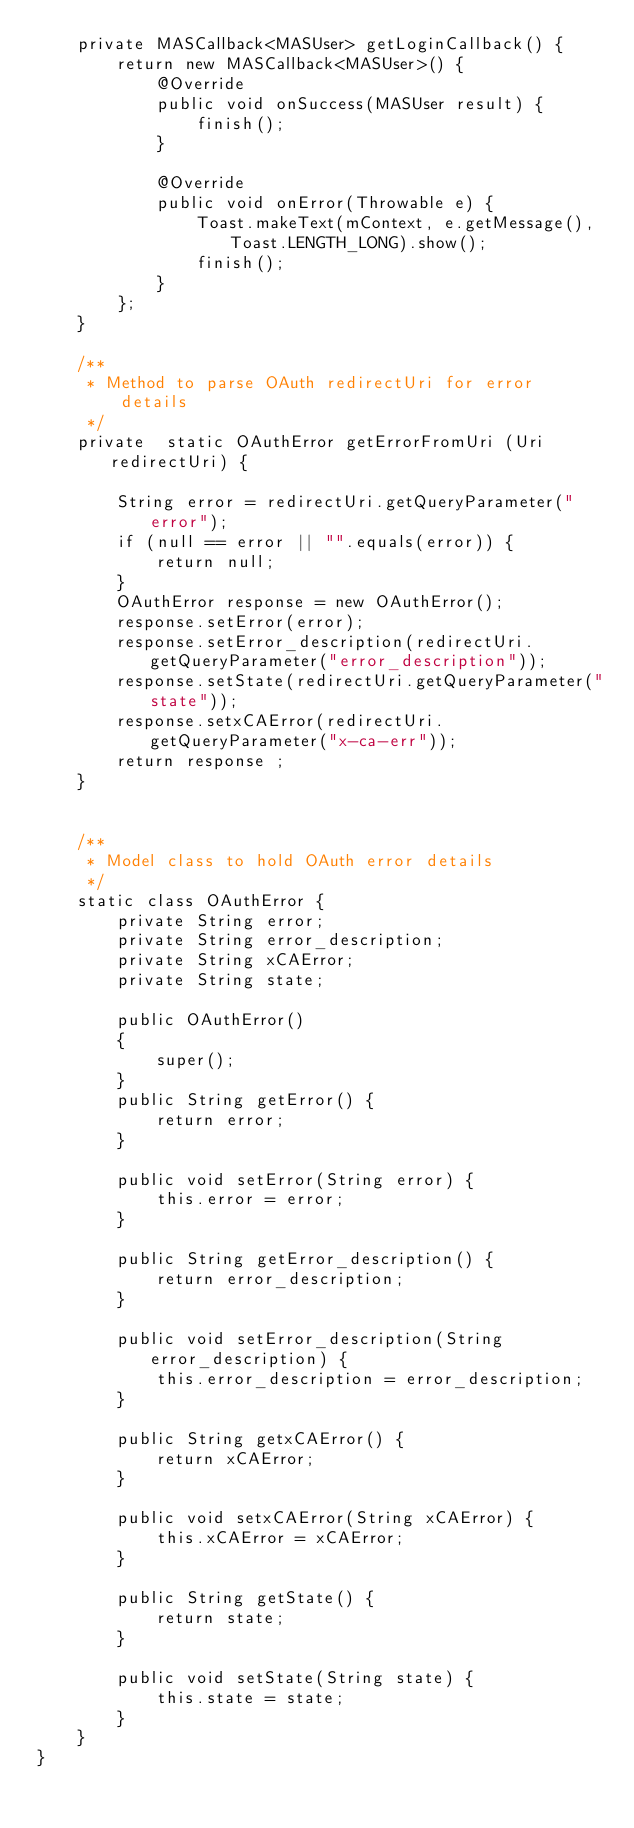Convert code to text. <code><loc_0><loc_0><loc_500><loc_500><_Java_>    private MASCallback<MASUser> getLoginCallback() {
        return new MASCallback<MASUser>() {
            @Override
            public void onSuccess(MASUser result) {
                finish();
            }

            @Override
            public void onError(Throwable e) {
                Toast.makeText(mContext, e.getMessage(), Toast.LENGTH_LONG).show();
                finish();
            }
        };
    }

    /**
     * Method to parse OAuth redirectUri for error details
     */
    private  static OAuthError getErrorFromUri (Uri redirectUri) {

        String error = redirectUri.getQueryParameter("error");
        if (null == error || "".equals(error)) {
            return null;
        }
        OAuthError response = new OAuthError();
        response.setError(error);
        response.setError_description(redirectUri.getQueryParameter("error_description"));
        response.setState(redirectUri.getQueryParameter("state"));
        response.setxCAError(redirectUri.getQueryParameter("x-ca-err"));
        return response ;
    }


    /**
     * Model class to hold OAuth error details
     */
    static class OAuthError {
        private String error;
        private String error_description;
        private String xCAError;
        private String state;

        public OAuthError()
        {
            super();
        }
        public String getError() {
            return error;
        }

        public void setError(String error) {
            this.error = error;
        }

        public String getError_description() {
            return error_description;
        }

        public void setError_description(String error_description) {
            this.error_description = error_description;
        }

        public String getxCAError() {
            return xCAError;
        }

        public void setxCAError(String xCAError) {
            this.xCAError = xCAError;
        }

        public String getState() {
            return state;
        }

        public void setState(String state) {
            this.state = state;
        }
    }
}

</code> 